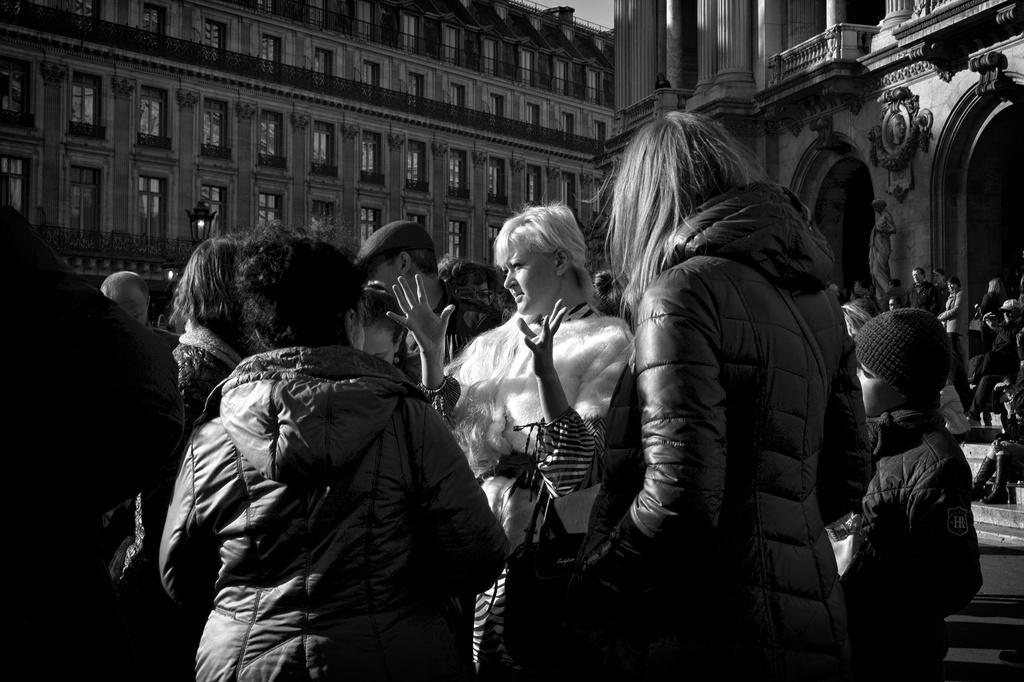Describe this image in one or two sentences. In this picture I can see there are few people standing. And there are buildings in the background. 